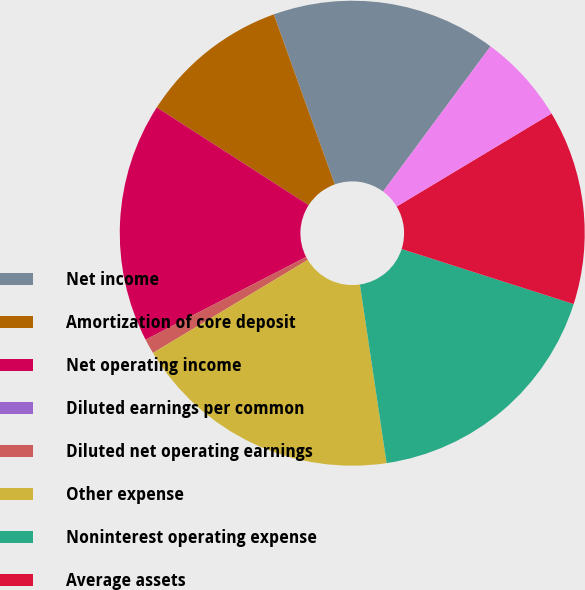Convert chart to OTSL. <chart><loc_0><loc_0><loc_500><loc_500><pie_chart><fcel>Net income<fcel>Amortization of core deposit<fcel>Net operating income<fcel>Diluted earnings per common<fcel>Diluted net operating earnings<fcel>Other expense<fcel>Noninterest operating expense<fcel>Average assets<fcel>Goodwill<nl><fcel>15.62%<fcel>10.42%<fcel>16.67%<fcel>0.0%<fcel>1.04%<fcel>18.75%<fcel>17.71%<fcel>13.54%<fcel>6.25%<nl></chart> 